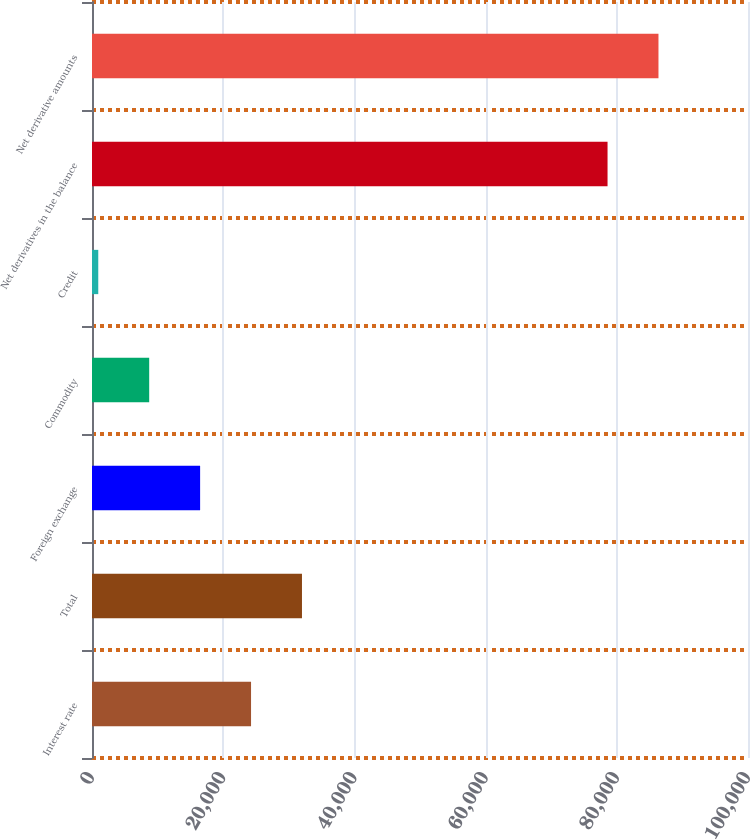Convert chart to OTSL. <chart><loc_0><loc_0><loc_500><loc_500><bar_chart><fcel>Interest rate<fcel>Total<fcel>Foreign exchange<fcel>Commodity<fcel>Credit<fcel>Net derivatives in the balance<fcel>Net derivative amounts<nl><fcel>24245.2<fcel>32008.6<fcel>16481.8<fcel>8718.4<fcel>955<fcel>78589<fcel>86352.4<nl></chart> 